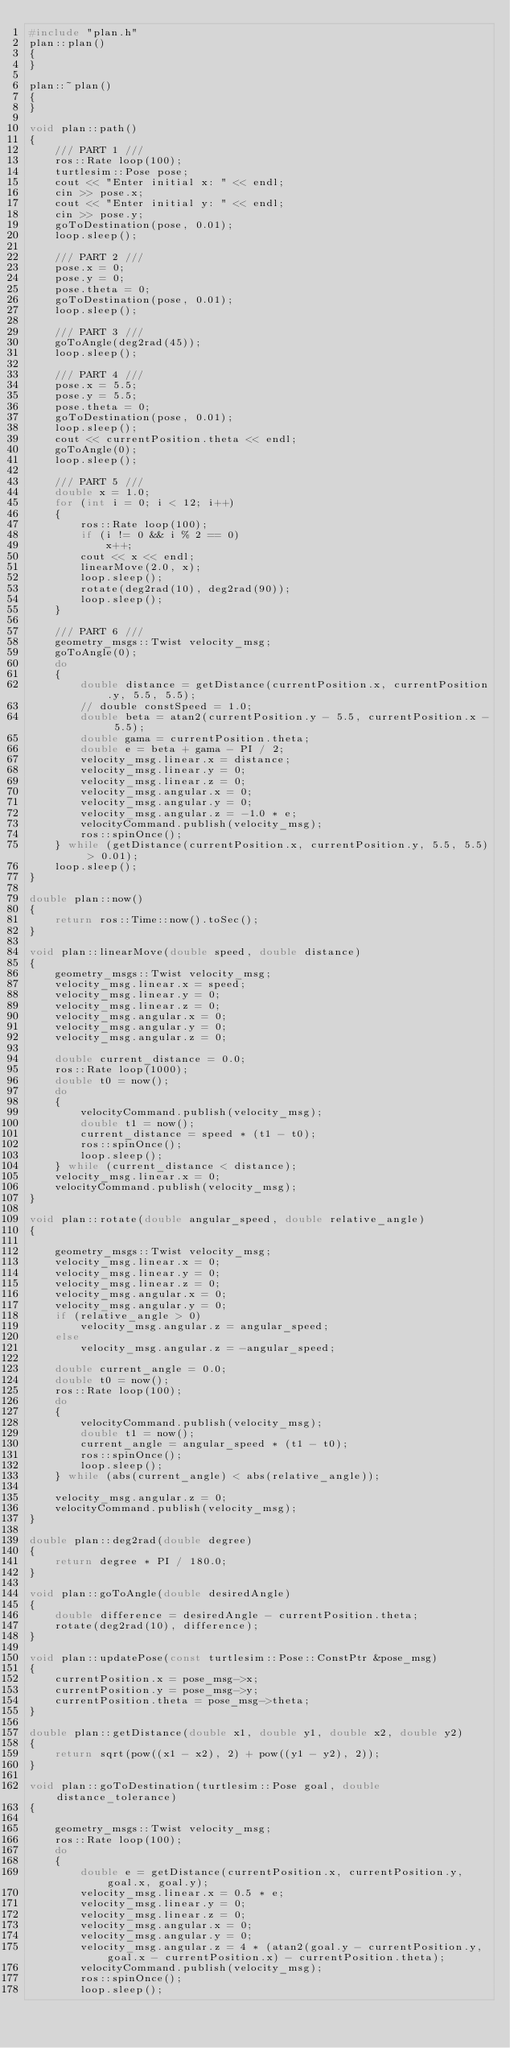<code> <loc_0><loc_0><loc_500><loc_500><_C++_>#include "plan.h"
plan::plan()
{
}

plan::~plan()
{
}

void plan::path()
{
    /// PART 1 ///
    ros::Rate loop(100);
    turtlesim::Pose pose;
    cout << "Enter initial x: " << endl;
    cin >> pose.x;
    cout << "Enter initial y: " << endl;
    cin >> pose.y;
    goToDestination(pose, 0.01);
    loop.sleep();

    /// PART 2 ///
    pose.x = 0;
    pose.y = 0;
    pose.theta = 0;
    goToDestination(pose, 0.01);
    loop.sleep();

    /// PART 3 ///
    goToAngle(deg2rad(45));
    loop.sleep();

    /// PART 4 ///
    pose.x = 5.5;
    pose.y = 5.5;
    pose.theta = 0;
    goToDestination(pose, 0.01);
    loop.sleep();
    cout << currentPosition.theta << endl;
    goToAngle(0);
    loop.sleep();

    /// PART 5 ///
    double x = 1.0;
    for (int i = 0; i < 12; i++)
    {
        ros::Rate loop(100);
        if (i != 0 && i % 2 == 0)
            x++;
        cout << x << endl;
        linearMove(2.0, x);
        loop.sleep();
        rotate(deg2rad(10), deg2rad(90));
        loop.sleep();
    }

    /// PART 6 ///
    geometry_msgs::Twist velocity_msg;
    goToAngle(0);
    do
    {
        double distance = getDistance(currentPosition.x, currentPosition.y, 5.5, 5.5);
        // double constSpeed = 1.0;
        double beta = atan2(currentPosition.y - 5.5, currentPosition.x - 5.5);
        double gama = currentPosition.theta;
        double e = beta + gama - PI / 2;
        velocity_msg.linear.x = distance;
        velocity_msg.linear.y = 0;
        velocity_msg.linear.z = 0;
        velocity_msg.angular.x = 0;
        velocity_msg.angular.y = 0;
        velocity_msg.angular.z = -1.0 * e;
        velocityCommand.publish(velocity_msg);
        ros::spinOnce();
    } while (getDistance(currentPosition.x, currentPosition.y, 5.5, 5.5) > 0.01);
    loop.sleep();
}

double plan::now()
{
    return ros::Time::now().toSec();
}

void plan::linearMove(double speed, double distance)
{
    geometry_msgs::Twist velocity_msg;
    velocity_msg.linear.x = speed;
    velocity_msg.linear.y = 0;
    velocity_msg.linear.z = 0;
    velocity_msg.angular.x = 0;
    velocity_msg.angular.y = 0;
    velocity_msg.angular.z = 0;

    double current_distance = 0.0;
    ros::Rate loop(1000);
    double t0 = now();
    do
    {
        velocityCommand.publish(velocity_msg);
        double t1 = now();
        current_distance = speed * (t1 - t0);
        ros::spinOnce();
        loop.sleep();
    } while (current_distance < distance);
    velocity_msg.linear.x = 0;
    velocityCommand.publish(velocity_msg);
}

void plan::rotate(double angular_speed, double relative_angle)
{

    geometry_msgs::Twist velocity_msg;
    velocity_msg.linear.x = 0;
    velocity_msg.linear.y = 0;
    velocity_msg.linear.z = 0;
    velocity_msg.angular.x = 0;
    velocity_msg.angular.y = 0;
    if (relative_angle > 0)
        velocity_msg.angular.z = angular_speed;
    else
        velocity_msg.angular.z = -angular_speed;

    double current_angle = 0.0;
    double t0 = now();
    ros::Rate loop(100);
    do
    {
        velocityCommand.publish(velocity_msg);
        double t1 = now();
        current_angle = angular_speed * (t1 - t0);
        ros::spinOnce();
        loop.sleep();
    } while (abs(current_angle) < abs(relative_angle));

    velocity_msg.angular.z = 0;
    velocityCommand.publish(velocity_msg);
}

double plan::deg2rad(double degree)
{
    return degree * PI / 180.0;
}

void plan::goToAngle(double desiredAngle)
{
    double difference = desiredAngle - currentPosition.theta;
    rotate(deg2rad(10), difference);
}

void plan::updatePose(const turtlesim::Pose::ConstPtr &pose_msg)
{
    currentPosition.x = pose_msg->x;
    currentPosition.y = pose_msg->y;
    currentPosition.theta = pose_msg->theta;
}

double plan::getDistance(double x1, double y1, double x2, double y2)
{
    return sqrt(pow((x1 - x2), 2) + pow((y1 - y2), 2));
}

void plan::goToDestination(turtlesim::Pose goal, double distance_tolerance)
{

    geometry_msgs::Twist velocity_msg;
    ros::Rate loop(100);
    do
    {
        double e = getDistance(currentPosition.x, currentPosition.y, goal.x, goal.y);
        velocity_msg.linear.x = 0.5 * e;
        velocity_msg.linear.y = 0;
        velocity_msg.linear.z = 0;
        velocity_msg.angular.x = 0;
        velocity_msg.angular.y = 0;
        velocity_msg.angular.z = 4 * (atan2(goal.y - currentPosition.y, goal.x - currentPosition.x) - currentPosition.theta);
        velocityCommand.publish(velocity_msg);
        ros::spinOnce();
        loop.sleep();
</code> 